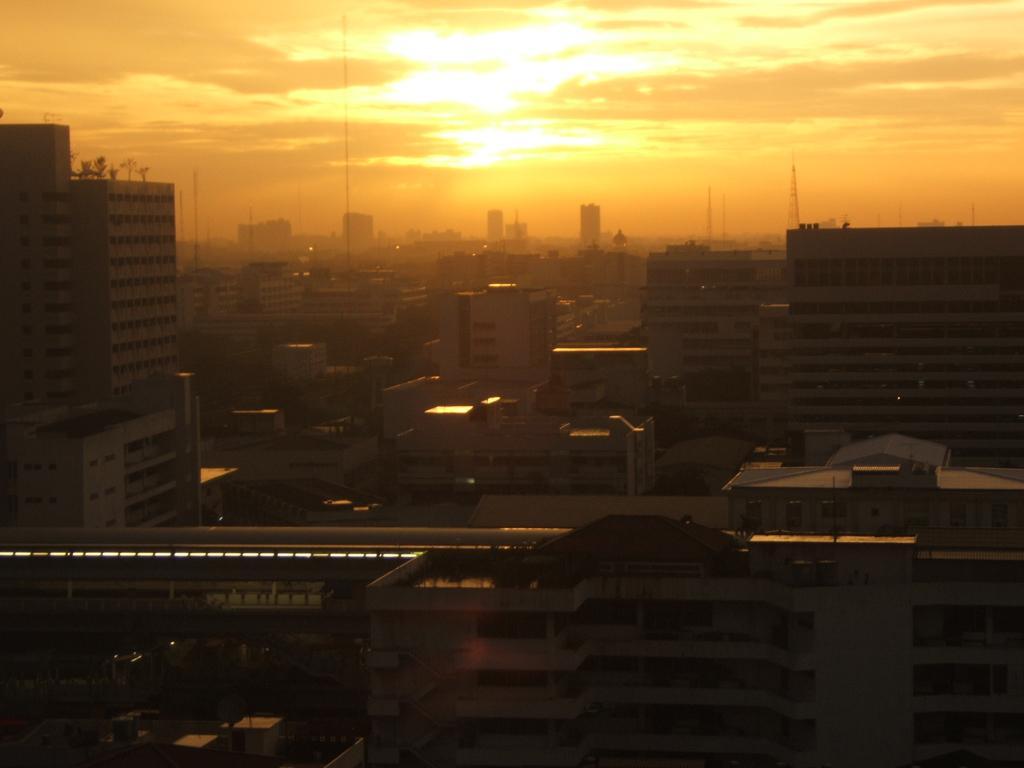Please provide a concise description of this image. In the center of the image there is a train. In the background of the image there are buildings, sun and sky. 